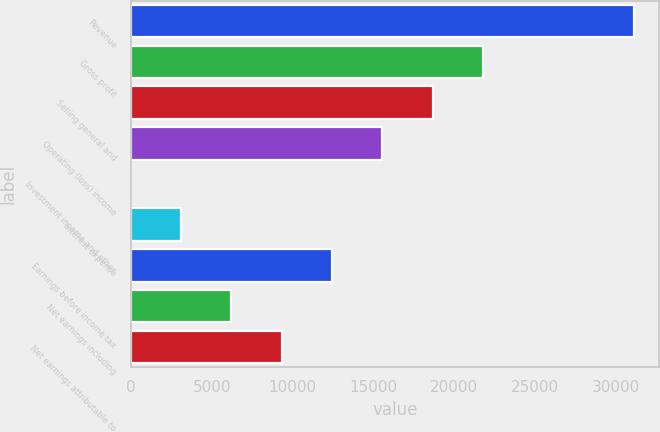Convert chart to OTSL. <chart><loc_0><loc_0><loc_500><loc_500><bar_chart><fcel>Revenue<fcel>Gross profit<fcel>Selling general and<fcel>Operating (loss) income<fcel>Investment income and other<fcel>Interest expense<fcel>Earnings before income tax<fcel>Net earnings including<fcel>Net earnings attributable to<nl><fcel>31092<fcel>21764.7<fcel>18655.6<fcel>15546.5<fcel>1<fcel>3110.1<fcel>12437.4<fcel>6219.2<fcel>9328.3<nl></chart> 